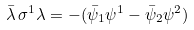Convert formula to latex. <formula><loc_0><loc_0><loc_500><loc_500>\bar { \lambda } \, \sigma ^ { 1 } \lambda = - ( \bar { \psi } _ { 1 } \psi ^ { 1 } - \bar { \psi } _ { 2 } \psi ^ { 2 } )</formula> 